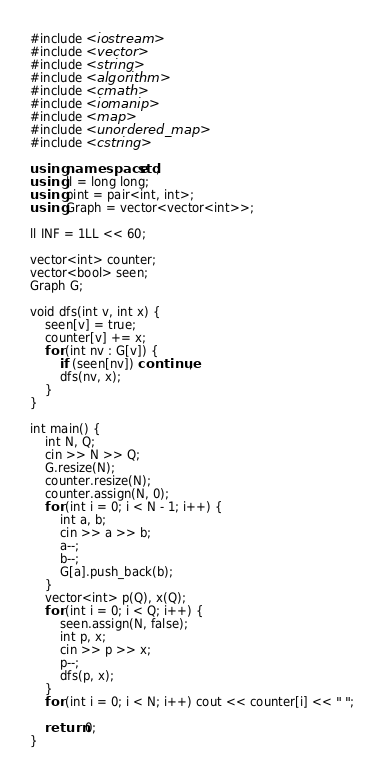<code> <loc_0><loc_0><loc_500><loc_500><_C++_>#include <iostream>
#include <vector>
#include <string>
#include <algorithm>
#include <cmath>
#include <iomanip>
#include <map>
#include <unordered_map>
#include <cstring>

using namespace std;
using ll = long long;
using pint = pair<int, int>;
using Graph = vector<vector<int>>;

ll INF = 1LL << 60;

vector<int> counter;
vector<bool> seen;
Graph G;

void dfs(int v, int x) {
	seen[v] = true;
	counter[v] += x;
	for (int nv : G[v]) {
		if (seen[nv]) continue;
		dfs(nv, x);
	}
}

int main() {
	int N, Q;
	cin >> N >> Q;
	G.resize(N);
	counter.resize(N);
	counter.assign(N, 0);
	for (int i = 0; i < N - 1; i++) {
		int a, b;
		cin >> a >> b;
		a--;
		b--;
		G[a].push_back(b);
	}
	vector<int> p(Q), x(Q);
	for (int i = 0; i < Q; i++) {
		seen.assign(N, false);
		int p, x;
		cin >> p >> x;
		p--;
		dfs(p, x);
	}
	for (int i = 0; i < N; i++) cout << counter[i] << " ";

	return 0;
}</code> 